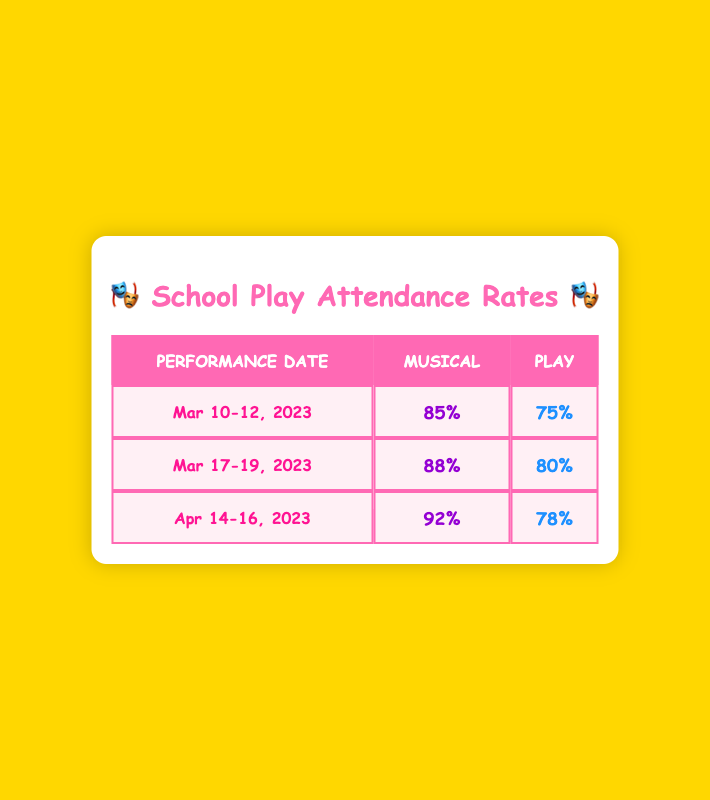What was the attendance rate for the Musical on April 14, 2023? The table lists the attendance rates for many performances. For April 14, 2023, under the Musical column, the entry shows an attendance rate of 92%.
Answer: 92% What was the attendance rate for the Play on March 11, 2023? From the table, we can find the entry for March 11, 2023, under the Play column, where it shows an attendance rate of 75%.
Answer: 75% Which type of show had the highest attendance rate overall? To determine the highest attendance rate, we compare all attendance rates for both Musicals and Plays. The highest attendance rate for Musicals is 92% (April 14, 2023), and for Plays, it is 80% (March 17, 2023). Therefore, the Musical had the highest attendance rate overall.
Answer: Musical What is the average attendance rate for Plays? We need to sum all the attendance rates for Plays: 75% (Mar 11) + 80% (Mar 17) + 72% (Mar 19) + 78% (Apr 15) = 305%. There are 4 entries, so the average is 305% / 4 = 76.25%.
Answer: 76.25% Did any show type reach an attendance rate of 90% or higher? Reviewing the attendance rates, we find that the Musical on April 14, 2023, has an attendance rate of 92%, which is higher than 90%. So yes, there was a show type that reached 90% or higher.
Answer: Yes What was the difference in attendance rates between the Musical on March 12, 2023, and the Play on March 19, 2023? The attendance rate for the Musical on March 12, 2023, is 90%, and the rate for the Play on March 19, 2023, is 72%. To find the difference, we subtract the Play's attendance from the Musical's: 90% - 72% = 18%.
Answer: 18% Which date had the lowest attendance rate for any type of show? By examining the attendance rates closely, the lowest rate appears under the Play on March 19, 2023, where the attendance is 72%. Therefore, this date had the lowest attendance rate overall.
Answer: March 19, 2023 What percentage of the total shows were Musicals? In total, there are 6 shows: 4 Musicals and 4 Plays. To find the percentage of Musicals, we use the formula: (Number of Musicals / Total Shows) * 100. Thus, (4 / 8) * 100 = 50%.
Answer: 50% 